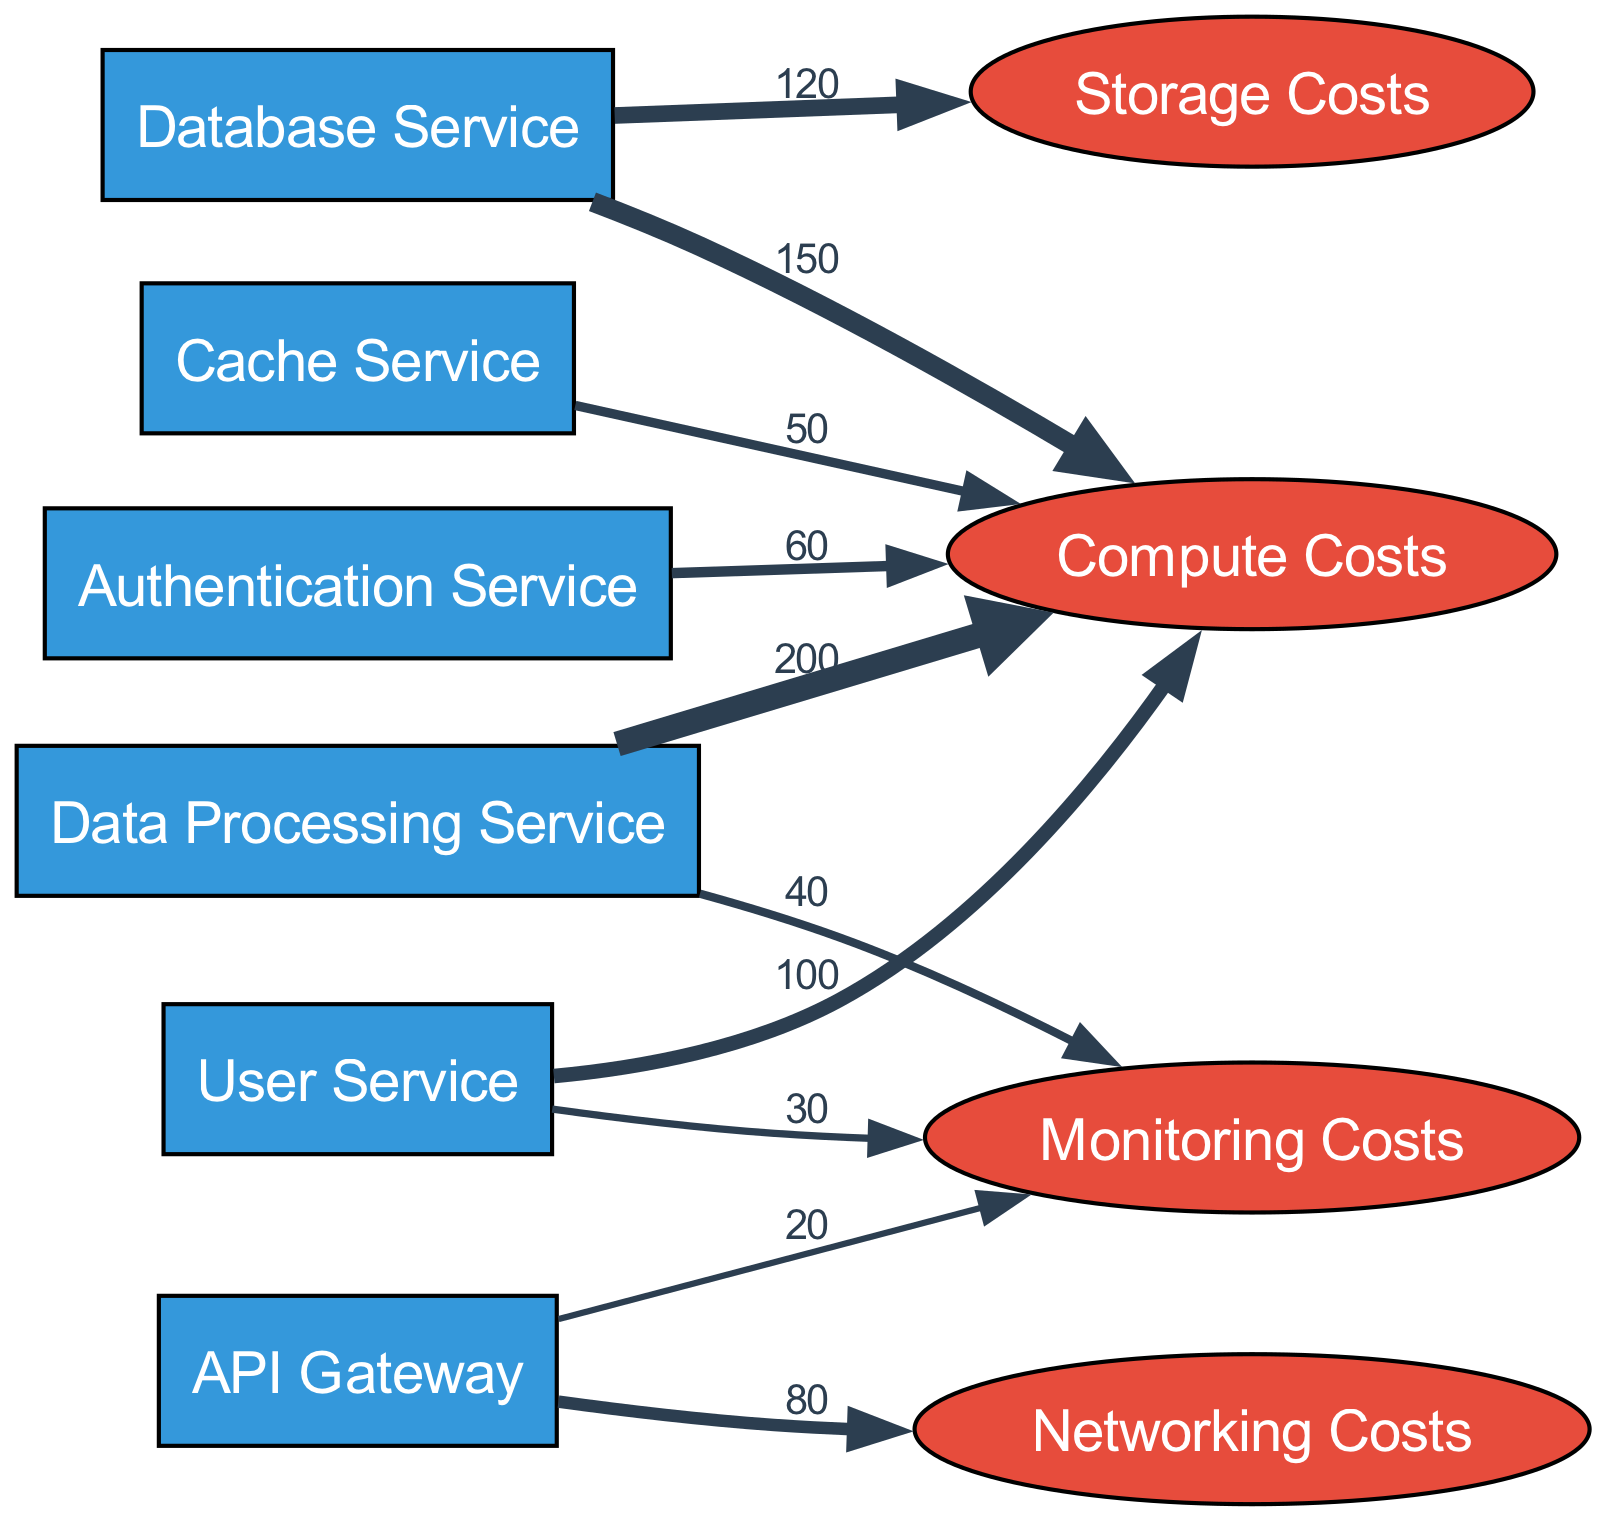What is the total value flowing into Compute Costs? To find the total value flowing into Compute Costs, I will add up all the values of the services connected to it: User Service (100), Database Service (150), Cache Service (50), Authentication Service (60), and Data Processing Service (200). The total is 100 + 150 + 50 + 60 + 200 = 560.
Answer: 560 How much does the Database Service contribute to Storage Costs? The Database Service has a direct link to Storage Costs with a value of 120. Therefore, the contribution is exactly that value.
Answer: 120 Which service has the lowest usage value? I will compare all the values connecting the services to their target costs. The values are: User Service (100), Database Service (150), Cache Service (50), API Gateway (80), Authentication Service (60), Data Processing Service (200). The lowest value is from Cache Service, which is 50.
Answer: Cache Service What is the total cost associated with Monitoring Costs? The Monitoring Costs receive values from User Service (30), API Gateway (20), and Data Processing Service (40). I will sum these values to find the total: 30 + 20 + 40 = 90.
Answer: 90 Which service has the highest total contribution across all costs? I will calculate the total contribution for each service by summing the values connected to each service: User Service (100 to Compute + 30 to Monitoring = 130), Database Service (150 to Compute + 120 to Storage = 270), Cache Service (50 to Compute = 50), API Gateway (80 to Networking + 20 to Monitoring = 100), Authentication Service (60 to Compute = 60), Data Processing Service (200 to Compute + 40 to Monitoring = 240). The highest total contribution is from Database Service with 270.
Answer: Database Service What kind of costs does the API Gateway incur? The API Gateway flows into two cost types: Networking Costs (with a value of 80) and Monitoring Costs (with a value of 20). Therefore, the types of costs incurred are Networking and Monitoring.
Answer: Networking, Monitoring 